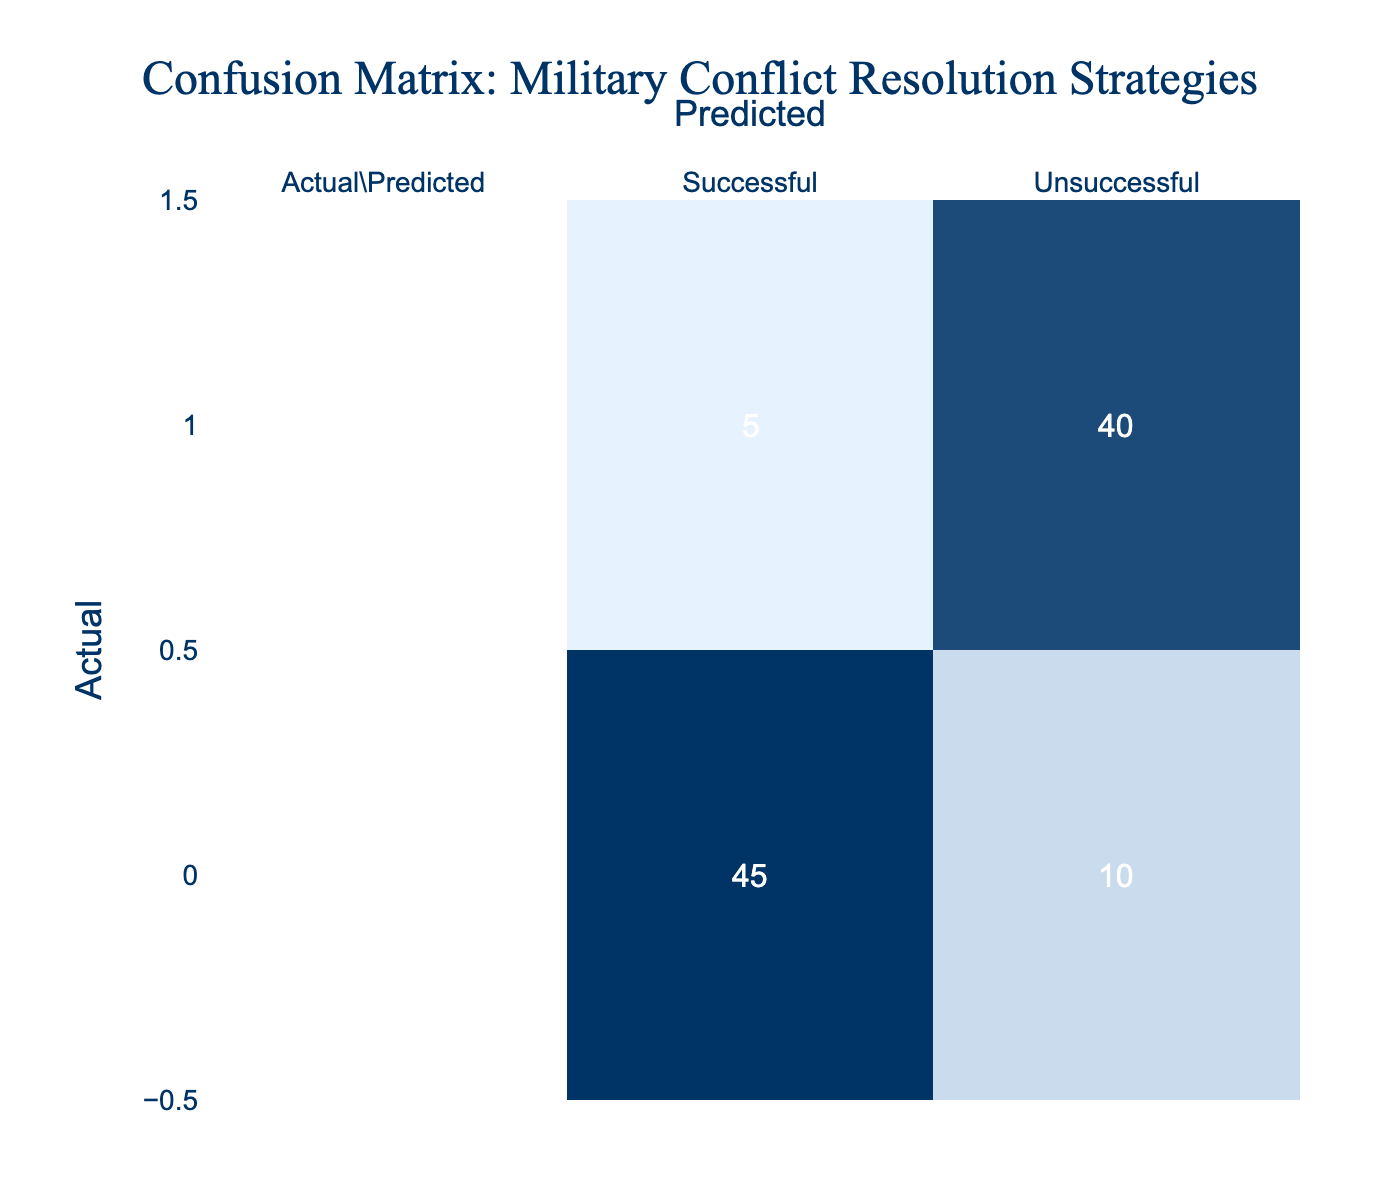What is the total number of actual successful outcomes? To find the total number of actual successful outcomes, we look at the "Successful" row under "Actual." The value there is 45.
Answer: 45 What is the total number of actual unsuccessful outcomes? We examine the "Unsuccessful" row under "Actual." The value there indicates there are 40 actual unsuccessful outcomes.
Answer: 40 What is the count of predicted successful outcomes? To find the count of predicted successful outcomes, we look at the "Successful" column under "Predicted." The value there is 45.
Answer: 45 What is the total number of predictions made? We can find the total number of predictions by adding all values in the confusion matrix: 45 (successful, successful) + 10 (unsuccessful, successful) + 5 (successful, unsuccessful) + 40 (unsuccessful, unsuccessful) = 100.
Answer: 100 What is the error rate for unsuccessful predictions? The error rate for unsuccessful predictions can be calculated using the formula (Number of false negatives + Number of false positives) / Total predictions. Here, false negatives are 5 and false positives are 10, so the error rate is (5 + 10) / 100 = 15%.
Answer: 15% Is the number of successful predictions higher than unsuccessful predictions? We compare the total successful predictions (45 + 10 = 55) to the total unsuccessful predictions (5 + 40 = 45). Since 55 is greater than 45, the statement is true.
Answer: Yes What is the precision of the strategy? Precision is calculated as True Positives / (True Positives + False Positives). Here, True Positives (successful, successful) = 45 and False Positives (unsuccessful, successful) = 10. Therefore, precision = 45 / (45 + 10) = 45 / 55 = 0.818 or 81.8%.
Answer: 81.8% How many more actual successful outcomes were predicted correctly compared to unsuccessful ones? We calculate the difference between the actual successful outcomes (45) and the actual unsuccessful outcomes predicted as successful (10). Thus, 45 - 10 = 35 more actual successful outcomes were predicted correctly than unsuccessful ones predicted as successful.
Answer: 35 What proportion of unsuccessful predictions were actually successful? The proportion is calculated as the false negatives (5) divided by the total predicted as unsuccessful (5 + 40 = 45). Therefore, the proportion is 5 / 45 = approximately 0.111 or 11.1%.
Answer: 11.1% 